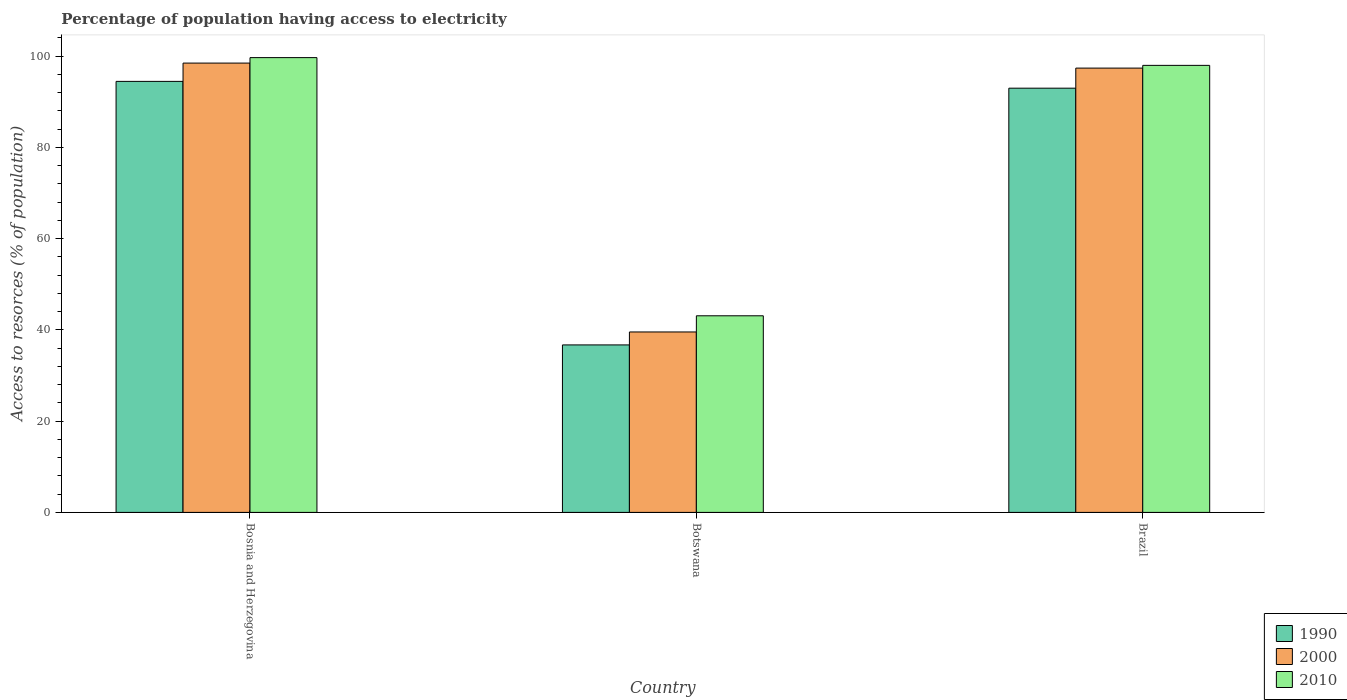How many different coloured bars are there?
Provide a short and direct response. 3. How many groups of bars are there?
Make the answer very short. 3. Are the number of bars per tick equal to the number of legend labels?
Your answer should be compact. Yes. What is the label of the 1st group of bars from the left?
Offer a very short reply. Bosnia and Herzegovina. What is the percentage of population having access to electricity in 2000 in Bosnia and Herzegovina?
Your answer should be very brief. 98.5. Across all countries, what is the maximum percentage of population having access to electricity in 2000?
Make the answer very short. 98.5. Across all countries, what is the minimum percentage of population having access to electricity in 2010?
Provide a succinct answer. 43.1. In which country was the percentage of population having access to electricity in 2010 maximum?
Offer a terse response. Bosnia and Herzegovina. In which country was the percentage of population having access to electricity in 1990 minimum?
Provide a short and direct response. Botswana. What is the total percentage of population having access to electricity in 2010 in the graph?
Give a very brief answer. 240.8. What is the difference between the percentage of population having access to electricity in 1990 in Bosnia and Herzegovina and that in Botswana?
Make the answer very short. 57.77. What is the difference between the percentage of population having access to electricity in 1990 in Bosnia and Herzegovina and the percentage of population having access to electricity in 2000 in Brazil?
Give a very brief answer. -2.91. What is the average percentage of population having access to electricity in 2010 per country?
Your response must be concise. 80.27. What is the difference between the percentage of population having access to electricity of/in 1990 and percentage of population having access to electricity of/in 2000 in Botswana?
Make the answer very short. -2.84. What is the ratio of the percentage of population having access to electricity in 2000 in Bosnia and Herzegovina to that in Brazil?
Make the answer very short. 1.01. Is the percentage of population having access to electricity in 1990 in Bosnia and Herzegovina less than that in Botswana?
Your answer should be very brief. No. Is the difference between the percentage of population having access to electricity in 1990 in Botswana and Brazil greater than the difference between the percentage of population having access to electricity in 2000 in Botswana and Brazil?
Provide a succinct answer. Yes. What is the difference between the highest and the second highest percentage of population having access to electricity in 2000?
Offer a very short reply. -1.1. What is the difference between the highest and the lowest percentage of population having access to electricity in 2010?
Provide a succinct answer. 56.6. In how many countries, is the percentage of population having access to electricity in 2010 greater than the average percentage of population having access to electricity in 2010 taken over all countries?
Provide a short and direct response. 2. What does the 3rd bar from the left in Botswana represents?
Give a very brief answer. 2010. What does the 3rd bar from the right in Botswana represents?
Your response must be concise. 1990. Are all the bars in the graph horizontal?
Your answer should be compact. No. How many countries are there in the graph?
Your answer should be compact. 3. Are the values on the major ticks of Y-axis written in scientific E-notation?
Ensure brevity in your answer.  No. Does the graph contain grids?
Your answer should be compact. No. Where does the legend appear in the graph?
Your answer should be compact. Bottom right. How many legend labels are there?
Give a very brief answer. 3. How are the legend labels stacked?
Make the answer very short. Vertical. What is the title of the graph?
Provide a succinct answer. Percentage of population having access to electricity. Does "1968" appear as one of the legend labels in the graph?
Offer a very short reply. No. What is the label or title of the X-axis?
Provide a short and direct response. Country. What is the label or title of the Y-axis?
Your response must be concise. Access to resorces (% of population). What is the Access to resorces (% of population) in 1990 in Bosnia and Herzegovina?
Offer a very short reply. 94.49. What is the Access to resorces (% of population) in 2000 in Bosnia and Herzegovina?
Keep it short and to the point. 98.5. What is the Access to resorces (% of population) of 2010 in Bosnia and Herzegovina?
Your response must be concise. 99.7. What is the Access to resorces (% of population) of 1990 in Botswana?
Offer a very short reply. 36.72. What is the Access to resorces (% of population) in 2000 in Botswana?
Make the answer very short. 39.56. What is the Access to resorces (% of population) of 2010 in Botswana?
Give a very brief answer. 43.1. What is the Access to resorces (% of population) of 1990 in Brazil?
Keep it short and to the point. 93. What is the Access to resorces (% of population) in 2000 in Brazil?
Give a very brief answer. 97.4. Across all countries, what is the maximum Access to resorces (% of population) of 1990?
Ensure brevity in your answer.  94.49. Across all countries, what is the maximum Access to resorces (% of population) of 2000?
Keep it short and to the point. 98.5. Across all countries, what is the maximum Access to resorces (% of population) in 2010?
Give a very brief answer. 99.7. Across all countries, what is the minimum Access to resorces (% of population) in 1990?
Your answer should be compact. 36.72. Across all countries, what is the minimum Access to resorces (% of population) in 2000?
Offer a terse response. 39.56. Across all countries, what is the minimum Access to resorces (% of population) of 2010?
Keep it short and to the point. 43.1. What is the total Access to resorces (% of population) of 1990 in the graph?
Your answer should be very brief. 224.2. What is the total Access to resorces (% of population) in 2000 in the graph?
Make the answer very short. 235.46. What is the total Access to resorces (% of population) of 2010 in the graph?
Give a very brief answer. 240.8. What is the difference between the Access to resorces (% of population) in 1990 in Bosnia and Herzegovina and that in Botswana?
Provide a succinct answer. 57.77. What is the difference between the Access to resorces (% of population) of 2000 in Bosnia and Herzegovina and that in Botswana?
Offer a terse response. 58.94. What is the difference between the Access to resorces (% of population) in 2010 in Bosnia and Herzegovina and that in Botswana?
Your response must be concise. 56.6. What is the difference between the Access to resorces (% of population) of 1990 in Bosnia and Herzegovina and that in Brazil?
Ensure brevity in your answer.  1.49. What is the difference between the Access to resorces (% of population) of 2000 in Bosnia and Herzegovina and that in Brazil?
Your answer should be compact. 1.1. What is the difference between the Access to resorces (% of population) in 2010 in Bosnia and Herzegovina and that in Brazil?
Keep it short and to the point. 1.7. What is the difference between the Access to resorces (% of population) of 1990 in Botswana and that in Brazil?
Your answer should be very brief. -56.28. What is the difference between the Access to resorces (% of population) in 2000 in Botswana and that in Brazil?
Offer a very short reply. -57.84. What is the difference between the Access to resorces (% of population) in 2010 in Botswana and that in Brazil?
Offer a terse response. -54.9. What is the difference between the Access to resorces (% of population) of 1990 in Bosnia and Herzegovina and the Access to resorces (% of population) of 2000 in Botswana?
Your answer should be very brief. 54.93. What is the difference between the Access to resorces (% of population) in 1990 in Bosnia and Herzegovina and the Access to resorces (% of population) in 2010 in Botswana?
Provide a short and direct response. 51.39. What is the difference between the Access to resorces (% of population) in 2000 in Bosnia and Herzegovina and the Access to resorces (% of population) in 2010 in Botswana?
Provide a succinct answer. 55.4. What is the difference between the Access to resorces (% of population) in 1990 in Bosnia and Herzegovina and the Access to resorces (% of population) in 2000 in Brazil?
Keep it short and to the point. -2.91. What is the difference between the Access to resorces (% of population) of 1990 in Bosnia and Herzegovina and the Access to resorces (% of population) of 2010 in Brazil?
Your answer should be compact. -3.51. What is the difference between the Access to resorces (% of population) in 2000 in Bosnia and Herzegovina and the Access to resorces (% of population) in 2010 in Brazil?
Your answer should be very brief. 0.5. What is the difference between the Access to resorces (% of population) of 1990 in Botswana and the Access to resorces (% of population) of 2000 in Brazil?
Your answer should be very brief. -60.68. What is the difference between the Access to resorces (% of population) of 1990 in Botswana and the Access to resorces (% of population) of 2010 in Brazil?
Your response must be concise. -61.28. What is the difference between the Access to resorces (% of population) in 2000 in Botswana and the Access to resorces (% of population) in 2010 in Brazil?
Ensure brevity in your answer.  -58.44. What is the average Access to resorces (% of population) in 1990 per country?
Offer a very short reply. 74.73. What is the average Access to resorces (% of population) in 2000 per country?
Make the answer very short. 78.49. What is the average Access to resorces (% of population) of 2010 per country?
Provide a succinct answer. 80.27. What is the difference between the Access to resorces (% of population) of 1990 and Access to resorces (% of population) of 2000 in Bosnia and Herzegovina?
Provide a succinct answer. -4.01. What is the difference between the Access to resorces (% of population) in 1990 and Access to resorces (% of population) in 2010 in Bosnia and Herzegovina?
Give a very brief answer. -5.21. What is the difference between the Access to resorces (% of population) of 2000 and Access to resorces (% of population) of 2010 in Bosnia and Herzegovina?
Provide a short and direct response. -1.2. What is the difference between the Access to resorces (% of population) of 1990 and Access to resorces (% of population) of 2000 in Botswana?
Provide a short and direct response. -2.84. What is the difference between the Access to resorces (% of population) in 1990 and Access to resorces (% of population) in 2010 in Botswana?
Your answer should be very brief. -6.38. What is the difference between the Access to resorces (% of population) in 2000 and Access to resorces (% of population) in 2010 in Botswana?
Your answer should be compact. -3.54. What is the difference between the Access to resorces (% of population) in 1990 and Access to resorces (% of population) in 2010 in Brazil?
Your answer should be compact. -5. What is the difference between the Access to resorces (% of population) in 2000 and Access to resorces (% of population) in 2010 in Brazil?
Give a very brief answer. -0.6. What is the ratio of the Access to resorces (% of population) in 1990 in Bosnia and Herzegovina to that in Botswana?
Give a very brief answer. 2.57. What is the ratio of the Access to resorces (% of population) in 2000 in Bosnia and Herzegovina to that in Botswana?
Your answer should be compact. 2.49. What is the ratio of the Access to resorces (% of population) of 2010 in Bosnia and Herzegovina to that in Botswana?
Your answer should be very brief. 2.31. What is the ratio of the Access to resorces (% of population) in 1990 in Bosnia and Herzegovina to that in Brazil?
Offer a terse response. 1.02. What is the ratio of the Access to resorces (% of population) in 2000 in Bosnia and Herzegovina to that in Brazil?
Your answer should be very brief. 1.01. What is the ratio of the Access to resorces (% of population) in 2010 in Bosnia and Herzegovina to that in Brazil?
Give a very brief answer. 1.02. What is the ratio of the Access to resorces (% of population) in 1990 in Botswana to that in Brazil?
Make the answer very short. 0.39. What is the ratio of the Access to resorces (% of population) in 2000 in Botswana to that in Brazil?
Your answer should be very brief. 0.41. What is the ratio of the Access to resorces (% of population) in 2010 in Botswana to that in Brazil?
Give a very brief answer. 0.44. What is the difference between the highest and the second highest Access to resorces (% of population) of 1990?
Keep it short and to the point. 1.49. What is the difference between the highest and the second highest Access to resorces (% of population) of 2010?
Offer a terse response. 1.7. What is the difference between the highest and the lowest Access to resorces (% of population) of 1990?
Offer a very short reply. 57.77. What is the difference between the highest and the lowest Access to resorces (% of population) of 2000?
Your answer should be very brief. 58.94. What is the difference between the highest and the lowest Access to resorces (% of population) in 2010?
Ensure brevity in your answer.  56.6. 